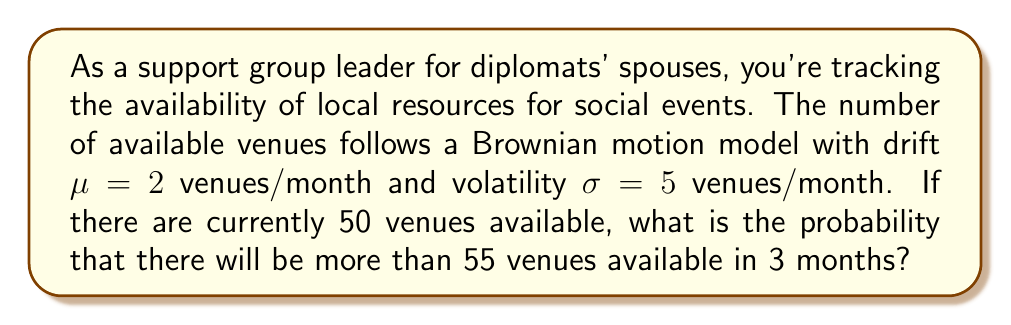What is the answer to this math problem? Let's approach this step-by-step:

1) In a Brownian motion model, the change in the number of venues over time follows a normal distribution.

2) The mean (expected value) of this change over time t is given by $\mu t$.
   In this case: $\mu t = 2 \times 3 = 6$ venues

3) The variance of this change over time t is given by $\sigma^2 t$.
   In this case: $\sigma^2 t = 5^2 \times 3 = 75$ venues^2

4) The standard deviation is the square root of the variance:
   $\sqrt{75} = \sqrt{25 \times 3} = 5\sqrt{3}$ venues

5) We want to find P(X > 55) where X is the number of venues after 3 months.
   Starting from 50 venues, this is equivalent to finding P(Change > 5).

6) We can standardize this to a Z-score:
   $$Z = \frac{\text{Change} - \text{Mean}}{\text{Standard Deviation}} = \frac{5 - 6}{5\sqrt{3}} = -\frac{1}{5\sqrt{3}}$$

7) We need to find P(Z > -1/(5√3)), which is equivalent to 1 - Φ(-1/(5√3)),
   where Φ is the cumulative distribution function of the standard normal distribution.

8) Using a standard normal table or calculator:
   1 - Φ(-1/(5√3)) ≈ 0.5388

Therefore, the probability of having more than 55 venues available in 3 months is approximately 0.5388 or 53.88%.
Answer: 0.5388 